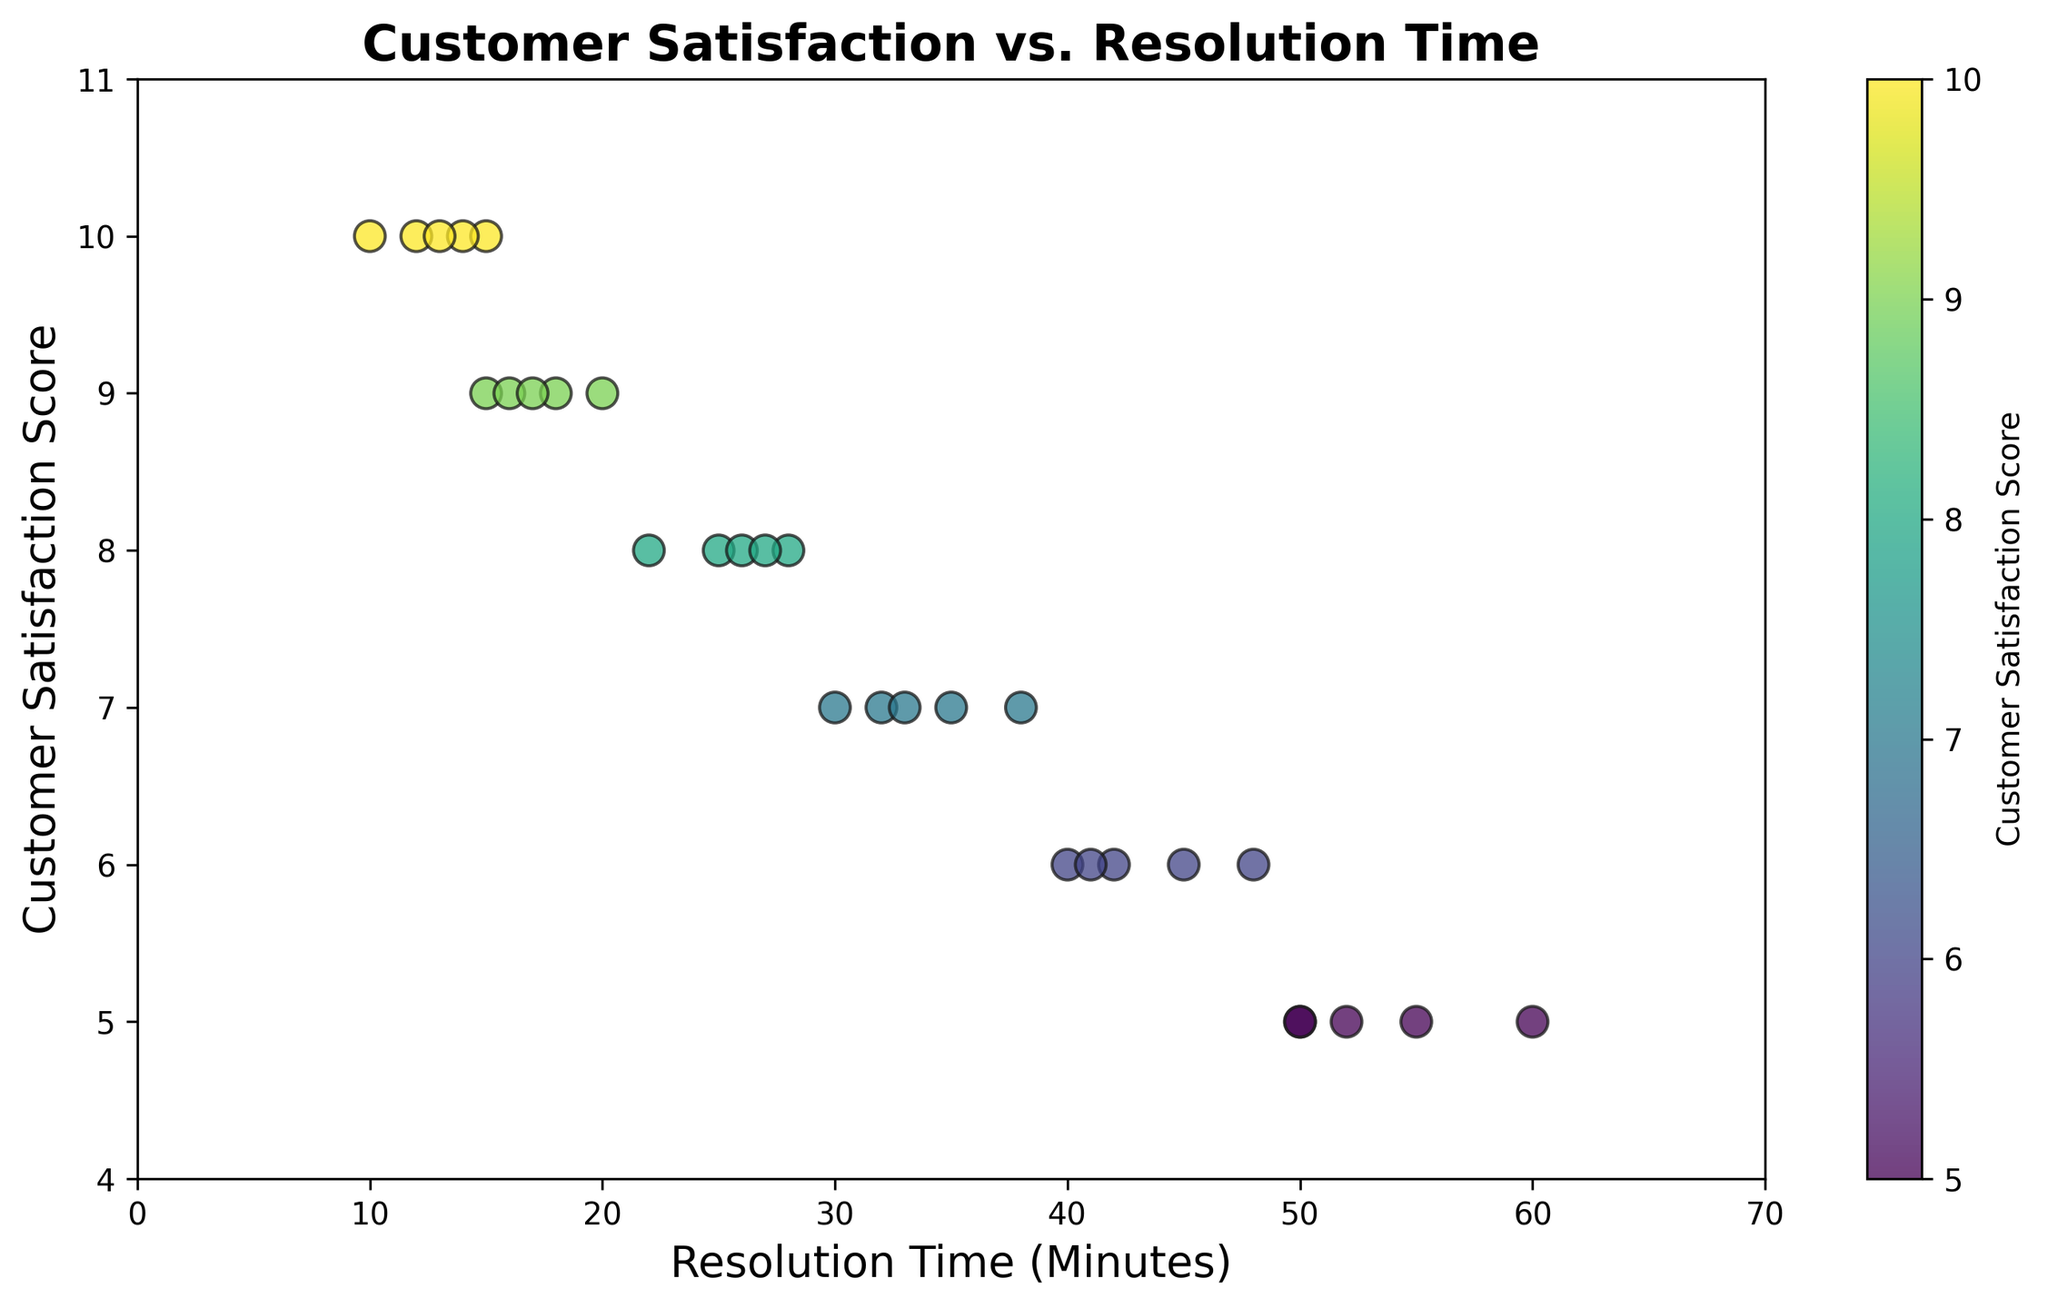What is the trend between resolution time and customer satisfaction score? By observing the scatter plot, we can see that as resolution time decreases, the customer satisfaction score tends to increase. The points with the lowest resolution times are clustered around higher satisfaction scores, indicating an inverse relationship between these two variables.
Answer: Inverse relationship Which resolution time corresponds to the highest customer satisfaction score? The scatter plot shows that the highest customer satisfaction score is 10. The resolution times corresponding to this score are around 10, 12, 13, 14, and 15 minutes, with 10 minutes being the lowest.
Answer: 10 minutes What is the approximate range of resolution times corresponding to a satisfaction score of 9? By looking at the scatter plot, we can see that the points representing a satisfaction score of 9 are scattered around resolution times of 15 to 20 minutes.
Answer: 15 to 20 minutes What is the color trend observed for higher customer satisfaction scores? In the scatter plot, higher customer satisfaction scores are represented by color gradients towards the green or yellow part of the viridis color map. This indicates that data points with higher customer satisfaction scores exhibit these colors.
Answer: Green/yellow Which resolution time has a wider spread in customer satisfaction scores, 20 minutes or 50 minutes? By examining the scatter plot, we can see that for the resolution time of 50 minutes, customer satisfaction scores range from 5 to 6. For the resolution time of 20 minutes, satisfaction scores range from 8 to 9. Therefore, the 50-minute resolution time has a wider spread in customer satisfaction scores.
Answer: 50 minutes What is the difference in the average customer satisfaction score between resolution times below 20 minutes and above 40 minutes? First, identify the customer satisfaction scores for resolution times below 20 minutes: 9, 10, 9, 10, 9, 10. The sum is 57, and the average is 57/6 = 9.5. For resolution times above 40 minutes: 6, 5, 6, 5, 6. The sum is 28, and the average is 28/5 = 5.6. The difference is 9.5 - 5.6.
Answer: 3.9 Are there any outliers in the data for customer satisfaction scores below 6? By closely inspecting the scatter plot, we can see that there are no points below a satisfaction score of 5. Therefore, satisfaction scores of 5 do not seem too distant from the trend and cannot be considered outliers.
Answer: No 